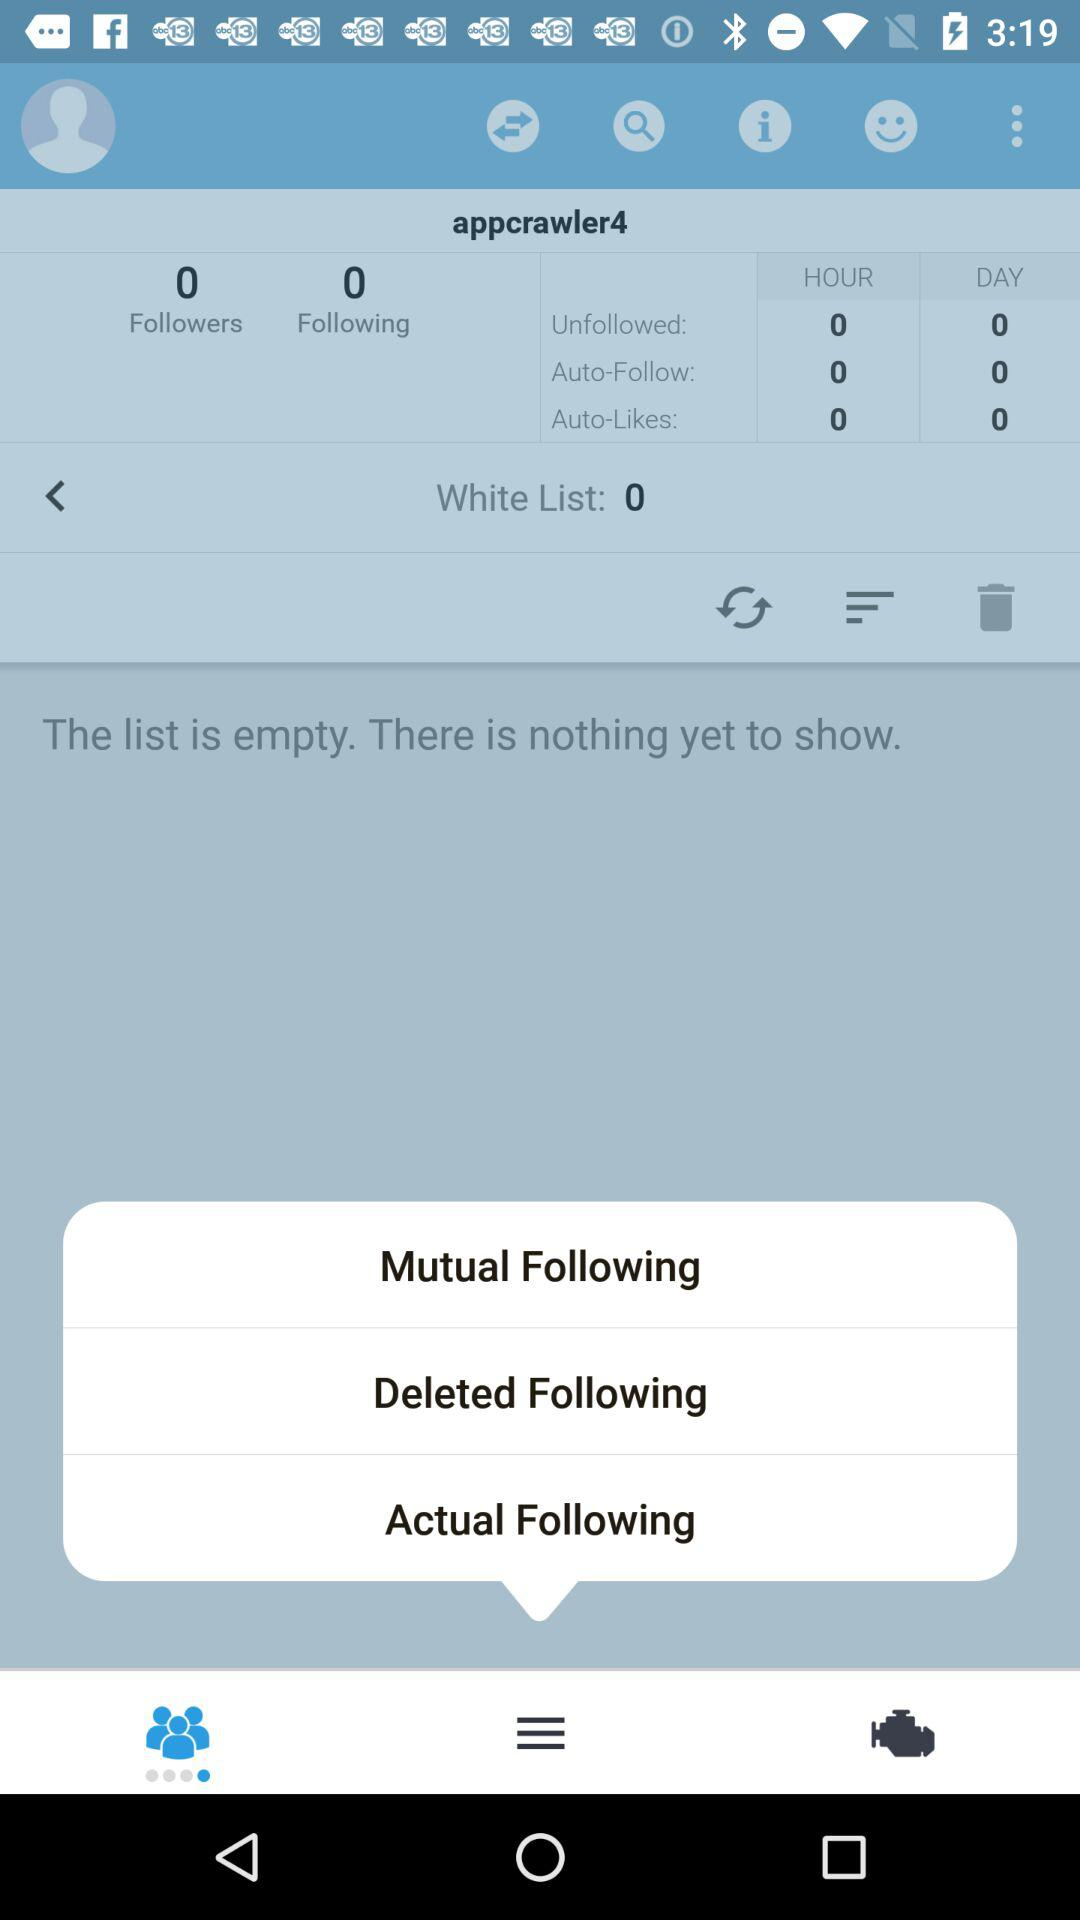How many items are there on the white list? There are 0 items. 